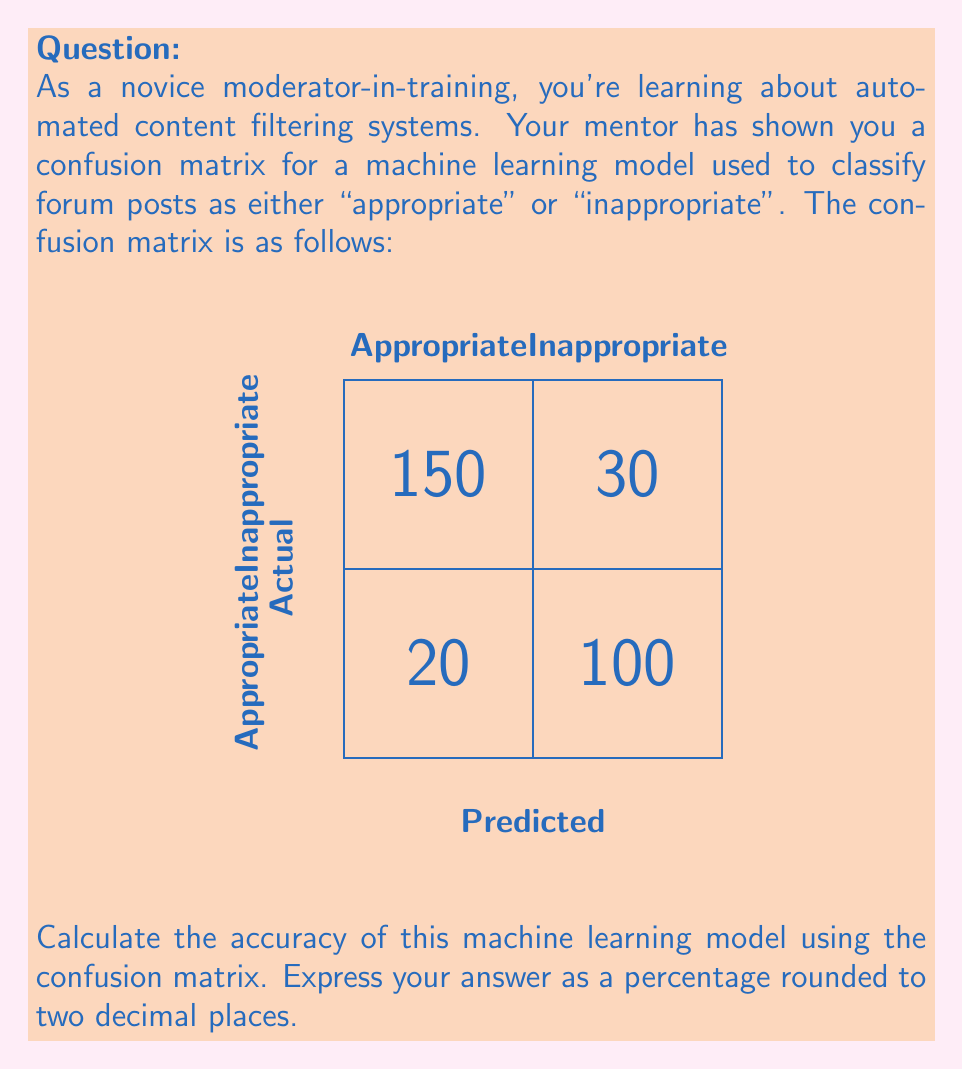Provide a solution to this math problem. Let's approach this step-by-step:

1) First, we need to understand what accuracy means in the context of a confusion matrix. Accuracy is the ratio of correct predictions to the total number of predictions.

2) In a confusion matrix:
   - True Positives (TP): Correctly predicted positive instances (Appropriate posts correctly classified as appropriate)
   - True Negatives (TN): Correctly predicted negative instances (Inappropriate posts correctly classified as inappropriate)
   - False Positives (FP): Incorrectly predicted positive instances (Inappropriate posts incorrectly classified as appropriate)
   - False Negatives (FN): Incorrectly predicted negative instances (Appropriate posts incorrectly classified as inappropriate)

3) From our confusion matrix:
   TP = 150
   TN = 100
   FP = 20
   FN = 30

4) The formula for accuracy is:

   $$ \text{Accuracy} = \frac{\text{TP} + \text{TN}}{\text{TP} + \text{TN} + \text{FP} + \text{FN}} $$

5) Let's substitute our values:

   $$ \text{Accuracy} = \frac{150 + 100}{150 + 100 + 20 + 30} = \frac{250}{300} $$

6) Now, let's calculate:

   $$ \frac{250}{300} = 0.8333... $$

7) Converting to a percentage and rounding to two decimal places:

   $$ 0.8333... \times 100\% \approx 83.33\% $$

Thus, the accuracy of the machine learning model is 83.33%.
Answer: 83.33% 